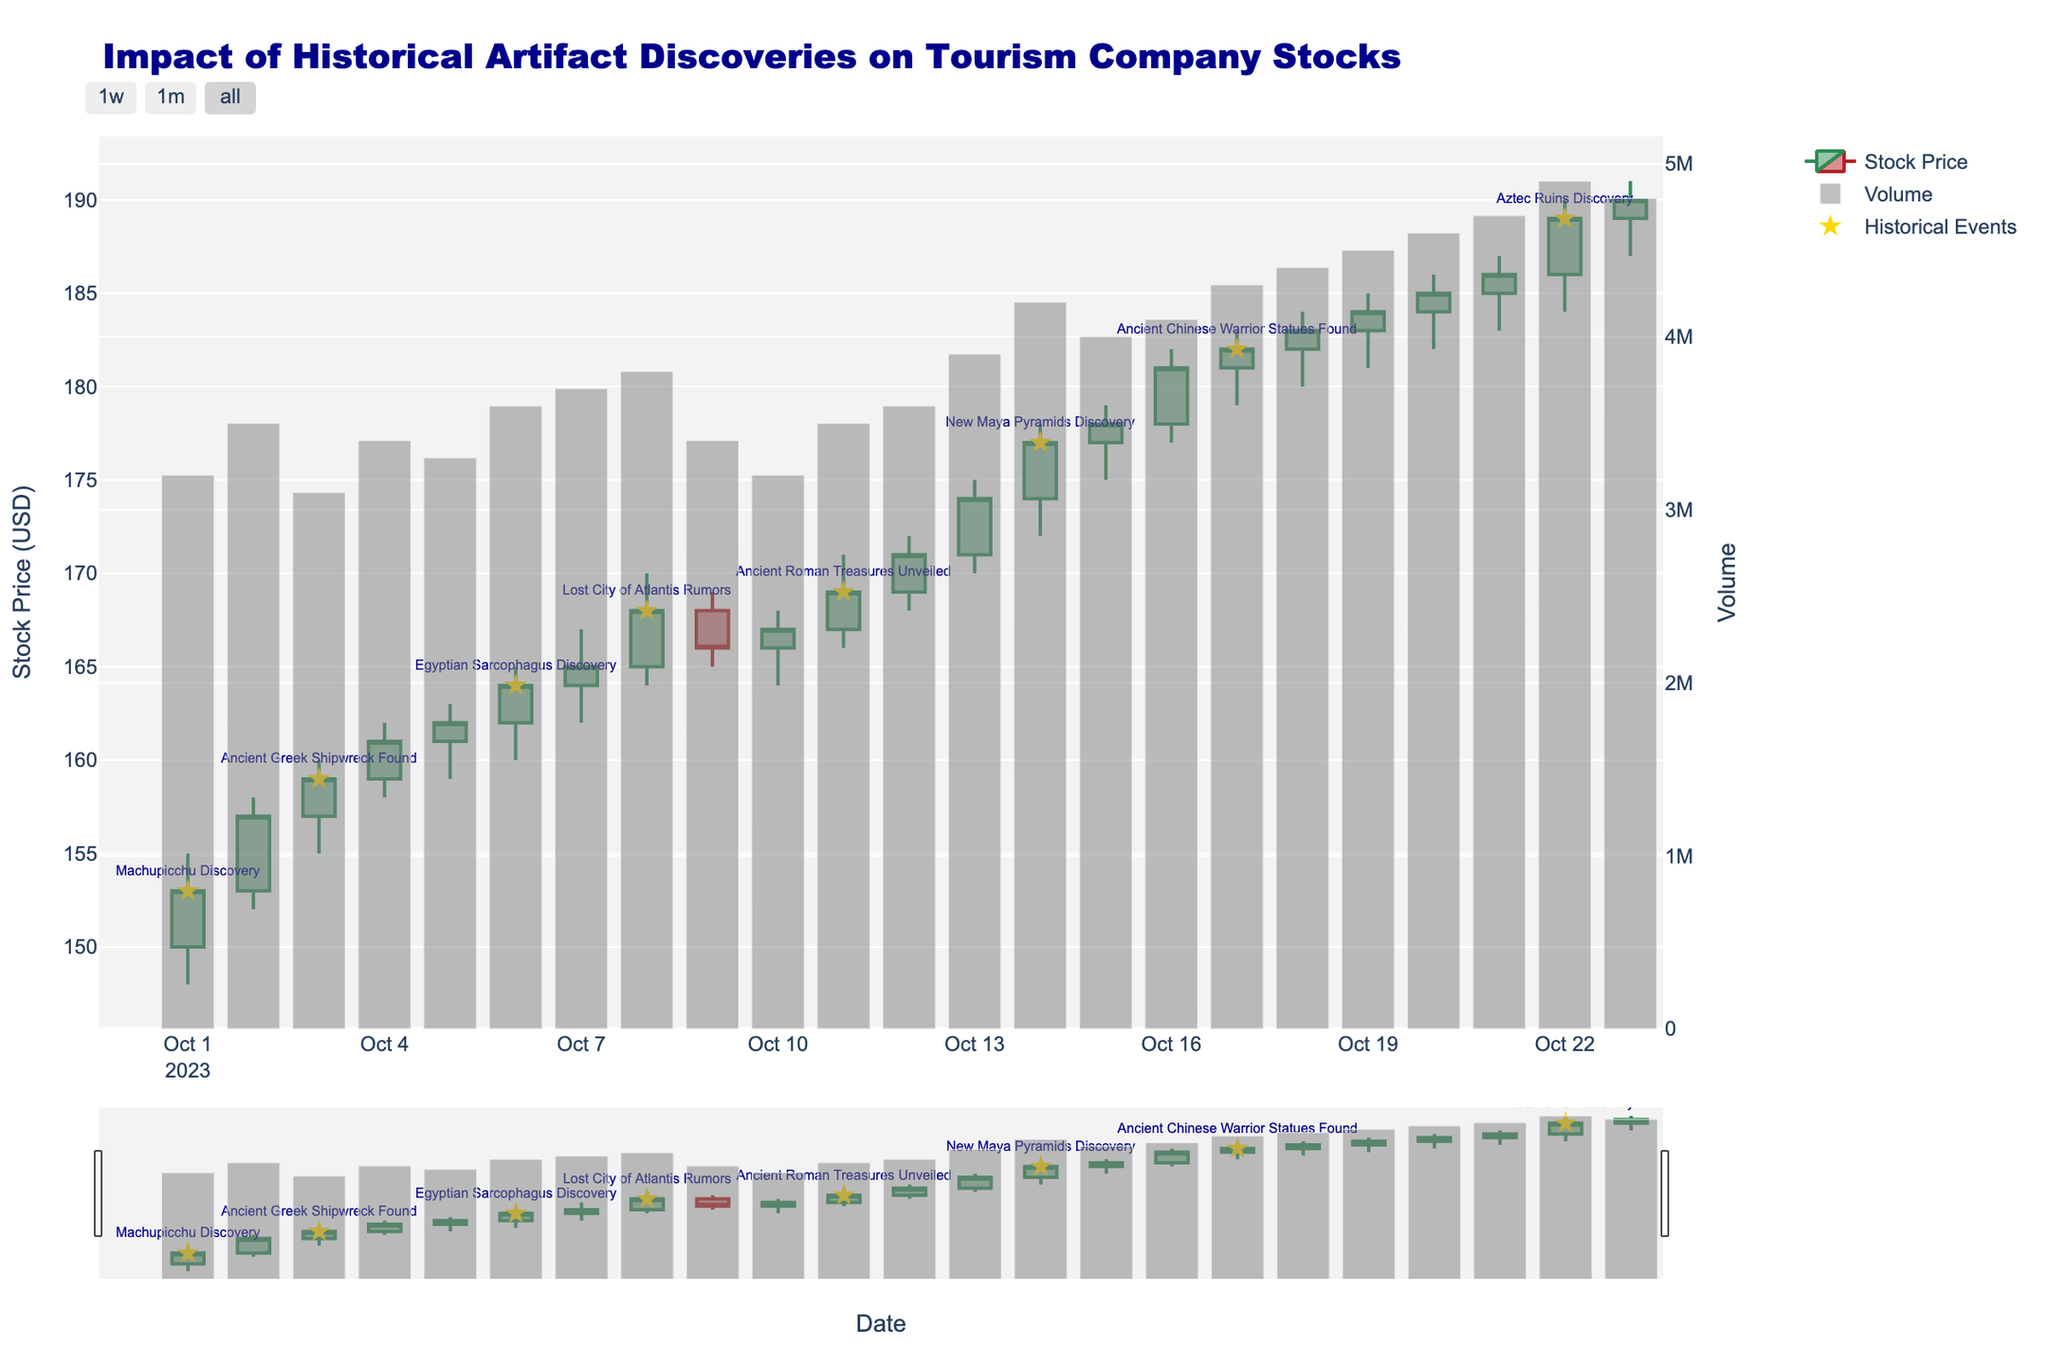What's the title of the plot? The plot title is usually located at the top center of the chart. By observing the figure, we can see the text displayed as the title.
Answer: Impact of Historical Artifact Discoveries on Tourism Company Stocks What is the general trend of the stock price over the period shown? To determine the trend, observe the general movement of the candlestick charts from the start to the end date. From October 1, 2023, to October 23, 2023, the stock price increases from around $150 to $190, indicating an upward trend.
Answer: Upward On which date did the stock have the highest closing price, and what was that price? Identify the candlestick with the highest closing value. By examining the plot, the highest closing value is observed on October 22, 2023. Hovering or visually checking the plot indicates that the price is $189.
Answer: October 22, 2023, $189 How does the stock price movement on October 14 relate to the discovered New Maya Pyramids event? Locate October 14 on the x-axis and check if there is an event marker. The plot shows a star marker indicating the event. The stock price rises from the previous close, closing higher on this date. This suggests a positive impact from the event.
Answer: Positive impact, stock price rose What was the volume on the day the Egyptian Sarcophagus was discovered, and how did it compare to the previous day? Locate October 6 on the x-axis for the volume bar and compare its height to October 5. The volume on October 6 was 3,600,000, whereas on October 5, it was 3,300,000. Thus, the volume increased by 300,000.
Answer: 3,600,000, increase of 300,000 What are the opening and closing prices on the day following the Lost City of Atlantis Rumors? Look at the candlestick on October 9, following October 8. The figure indicates the opening price is $168 and the closing price is $166.
Answer: Opening $168, Closing $166 Compare the stock movement on the day of the Machupicchu Discovery with the day of Ancient Chinese Warrior Statues Found. Find the corresponding dates, October 1 and October 17. On October 1, the opening was $150, and the close was $153 (positive move). On October 17, the opening was $181, and the close was $182 (small positive move). Both days show positive movement, with a larger gain on October 1.
Answer: Both positive movements, with a larger gain on October 1 How many historical events are marked in the plot? Count the number of star markers in the figure, which represent historical events. By scanning through the plot, we count a total of 8 events.
Answer: 8 What pattern do you observe in stock price movements following discoveries of major artifacts? By examining the plot after major discovery dates (marked with stars), we generally observe that the stock price tends to rise after these events. For example, rises are seen after Machupicchu Discovery, New Maya Pyramids Discovery, etc.
Answer: Stock price tends to rise Which day saw the highest volume of traded stocks and what was the impact on the stock price? Observe the volume bars to identify the highest one, which is on October 22, with a volume of 4,900,000. The stock closed higher on this date, showing a positive impact of the increased volume.
Answer: October 22, positive impact 